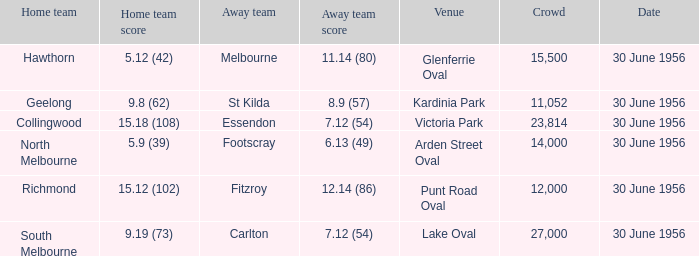What is the home team for punt road oval? Richmond. 